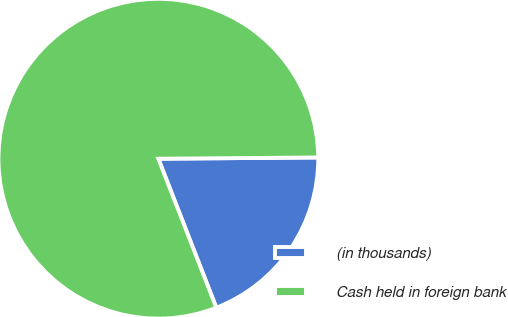<chart> <loc_0><loc_0><loc_500><loc_500><pie_chart><fcel>(in thousands)<fcel>Cash held in foreign bank<nl><fcel>19.22%<fcel>80.78%<nl></chart> 